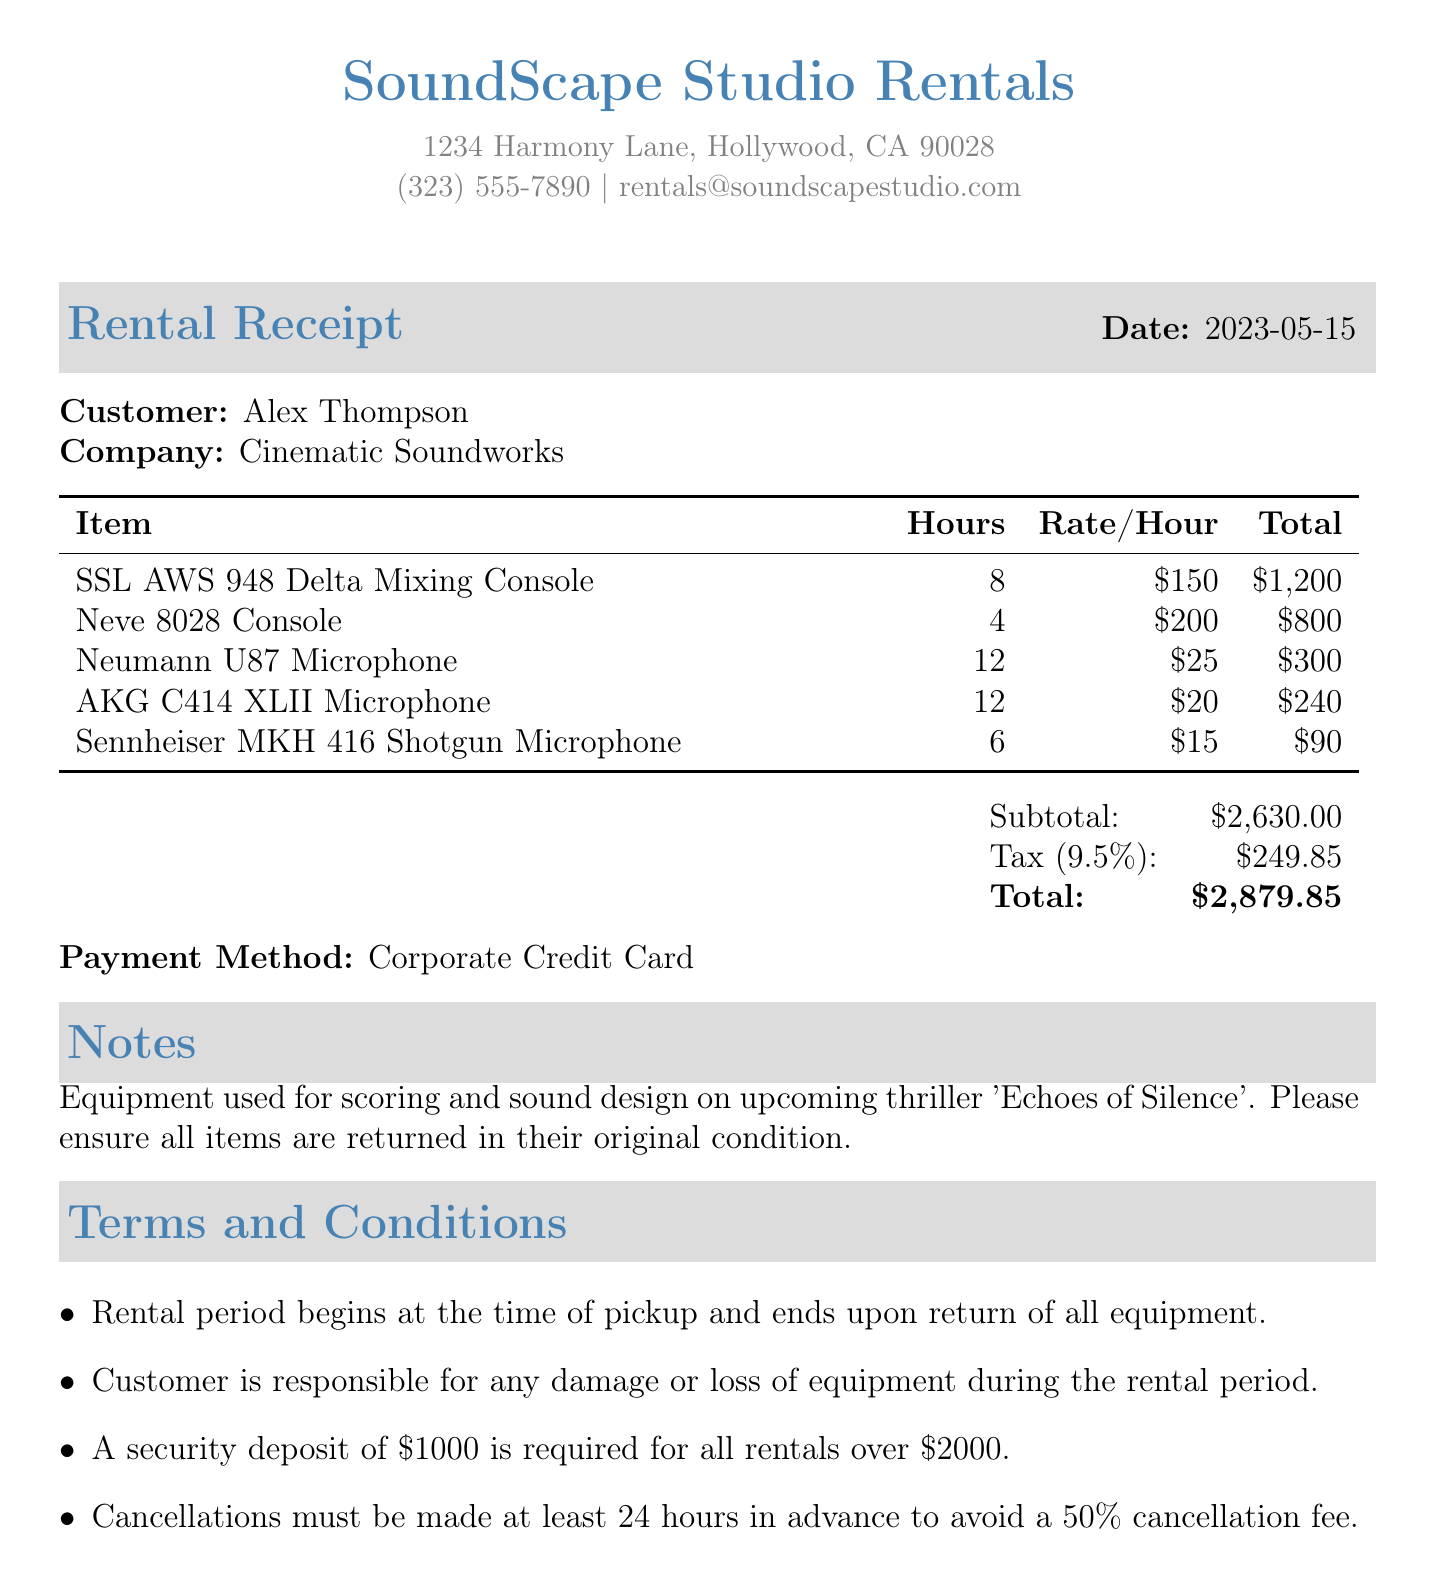What is the company name? The company name is listed at the top of the receipt and is "SoundScape Studio Rentals."
Answer: SoundScape Studio Rentals What is the total amount charged? The total amount is clearly stated in the receipt under the summary section, which combines subtotal and tax.
Answer: $2879.85 Who is the customer? The customer’s name is provided in the receipt, specifically detailing the recipient of the services.
Answer: Alex Thompson What is the tax rate applied? The tax rate is mentioned alongside the tax amount calculation in the document.
Answer: 9.5% How many hours was the Neumann U87 Microphone rented? The total hours for this specific microphone are indicated in the itemized list of rental items.
Answer: 12 What is the subtotal before tax? The subtotal is explicitly mentioned in the summary of the receipt, representing the cost of rental items before tax.
Answer: $2630.00 What method was used for payment? The payment method is specified in the document and indicates how the charges were settled.
Answer: Corporate Credit Card What is a requirement for rentals over $2000? The terms and conditions outline specific conditions related to higher rental amounts, highlighting a particular need.
Answer: A security deposit of $1000 What was the equipment used for? The notes section mentions the purpose of the equipment rented in relation to film production.
Answer: Scoring and sound design on upcoming thriller 'Echoes of Silence' 